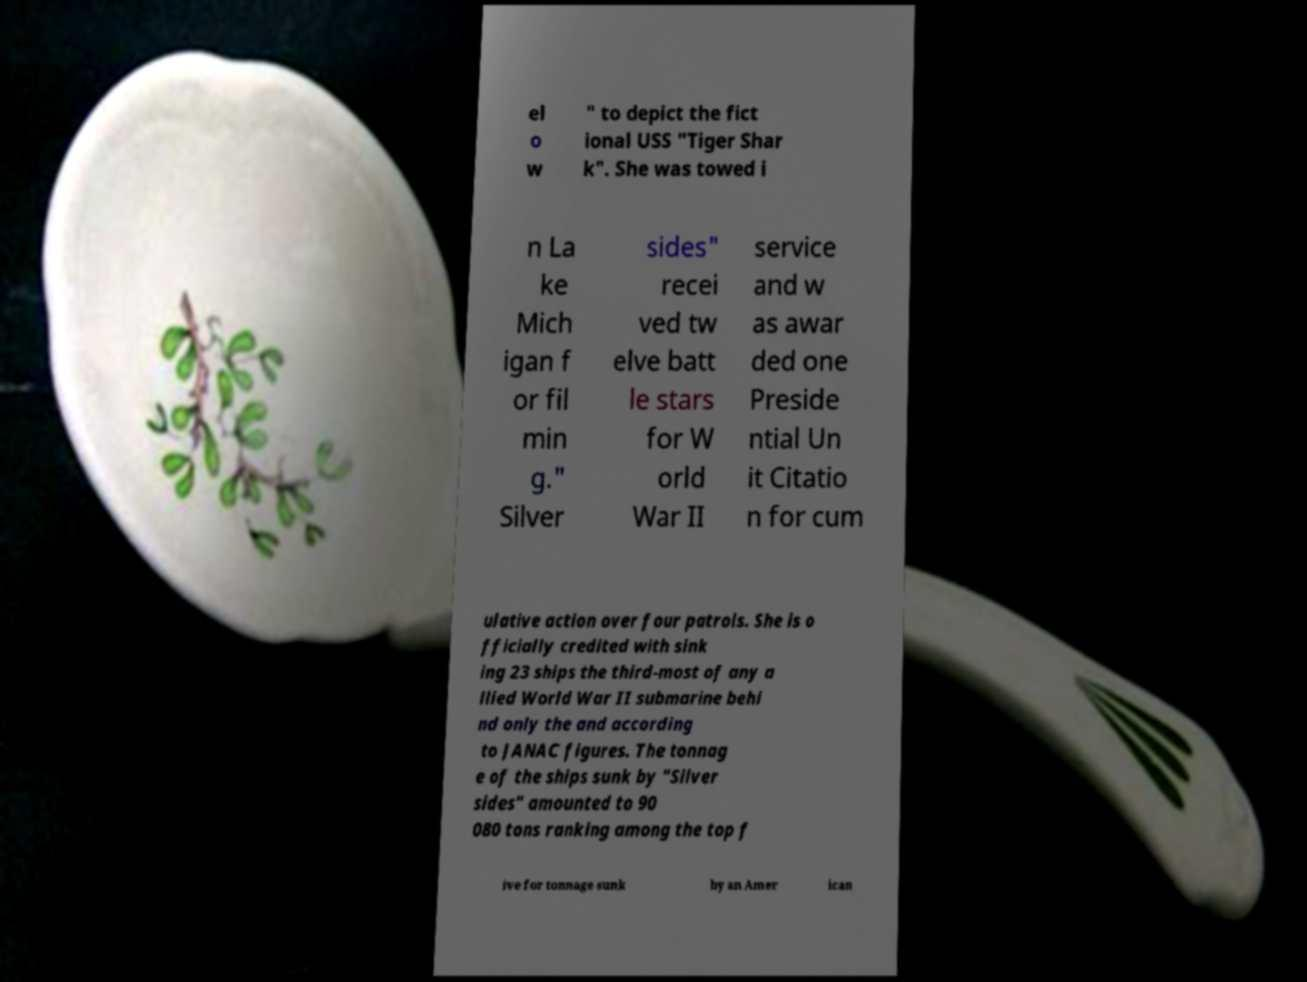Can you accurately transcribe the text from the provided image for me? el o w " to depict the fict ional USS "Tiger Shar k". She was towed i n La ke Mich igan f or fil min g." Silver sides" recei ved tw elve batt le stars for W orld War II service and w as awar ded one Preside ntial Un it Citatio n for cum ulative action over four patrols. She is o fficially credited with sink ing 23 ships the third-most of any a llied World War II submarine behi nd only the and according to JANAC figures. The tonnag e of the ships sunk by "Silver sides" amounted to 90 080 tons ranking among the top f ive for tonnage sunk by an Amer ican 